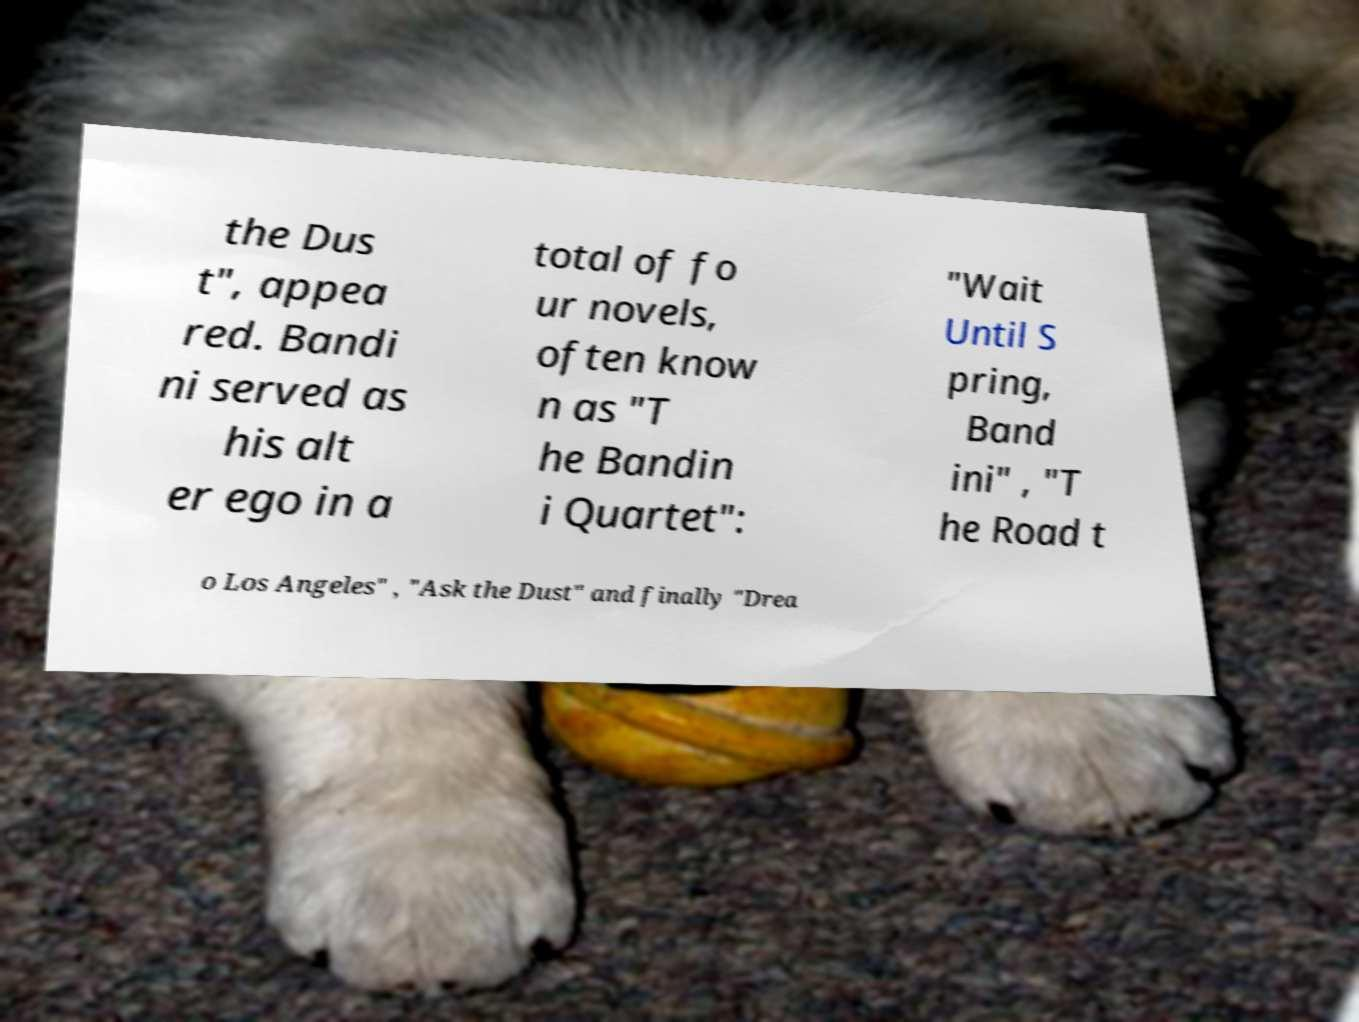For documentation purposes, I need the text within this image transcribed. Could you provide that? the Dus t", appea red. Bandi ni served as his alt er ego in a total of fo ur novels, often know n as "T he Bandin i Quartet": "Wait Until S pring, Band ini" , "T he Road t o Los Angeles" , "Ask the Dust" and finally "Drea 